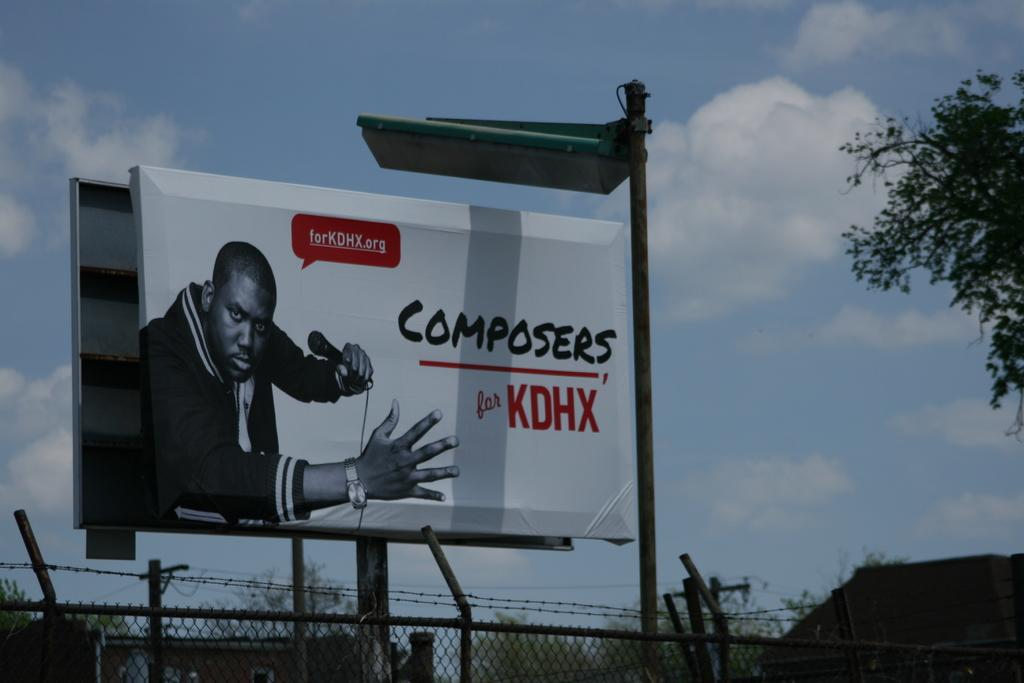<image>
Relay a brief, clear account of the picture shown. A sign has the word composers on it next to a man. 